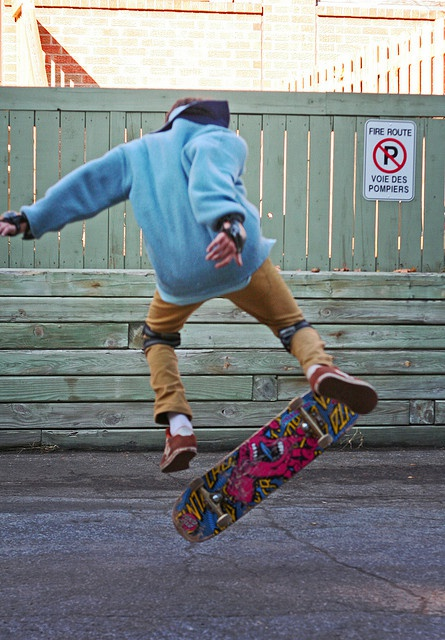Describe the objects in this image and their specific colors. I can see people in salmon, lightblue, gray, black, and maroon tones and skateboard in salmon, black, maroon, gray, and navy tones in this image. 